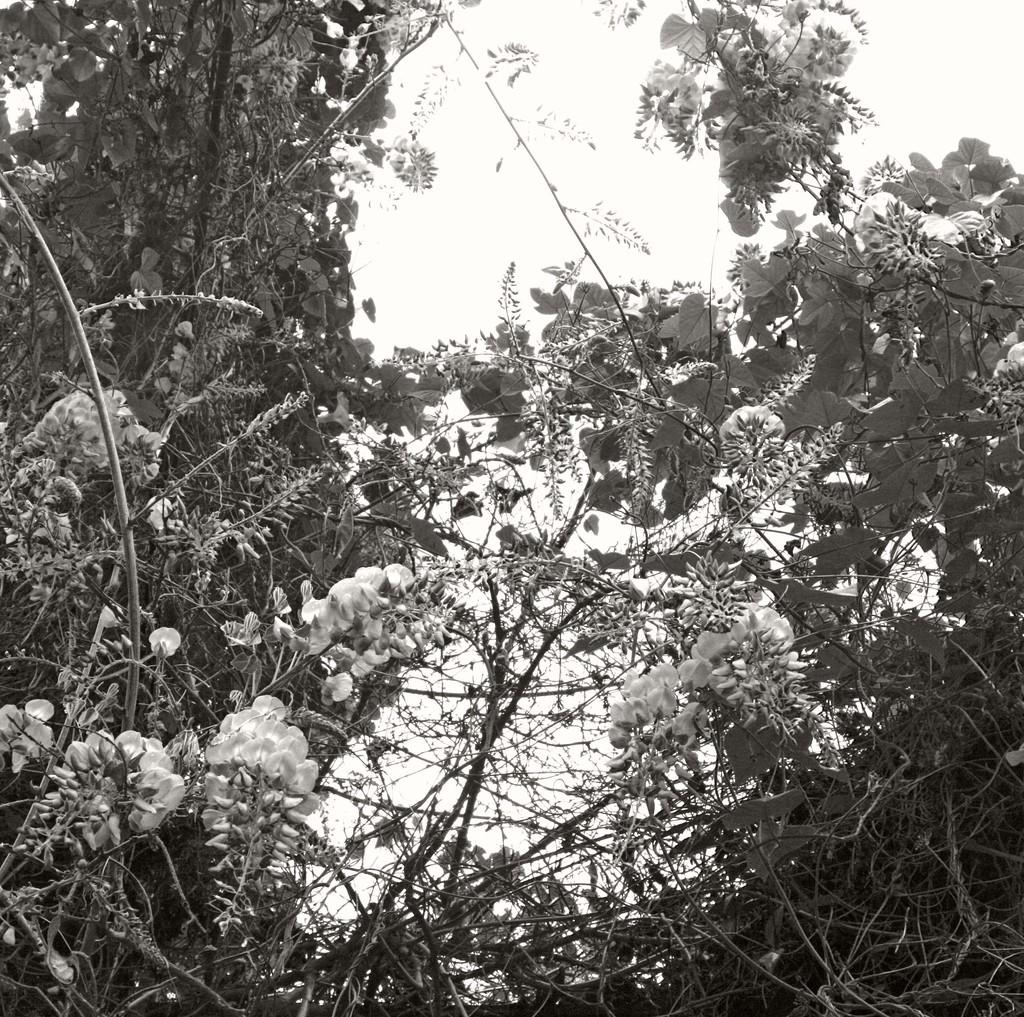What is the main feature of the image? The main feature of the image is the presence of a lot of trees. What color scheme is used in the image? The image is in black and white color. What type of weather can be seen in the image? The image is in black and white, so it is not possible to determine the weather from the image. 